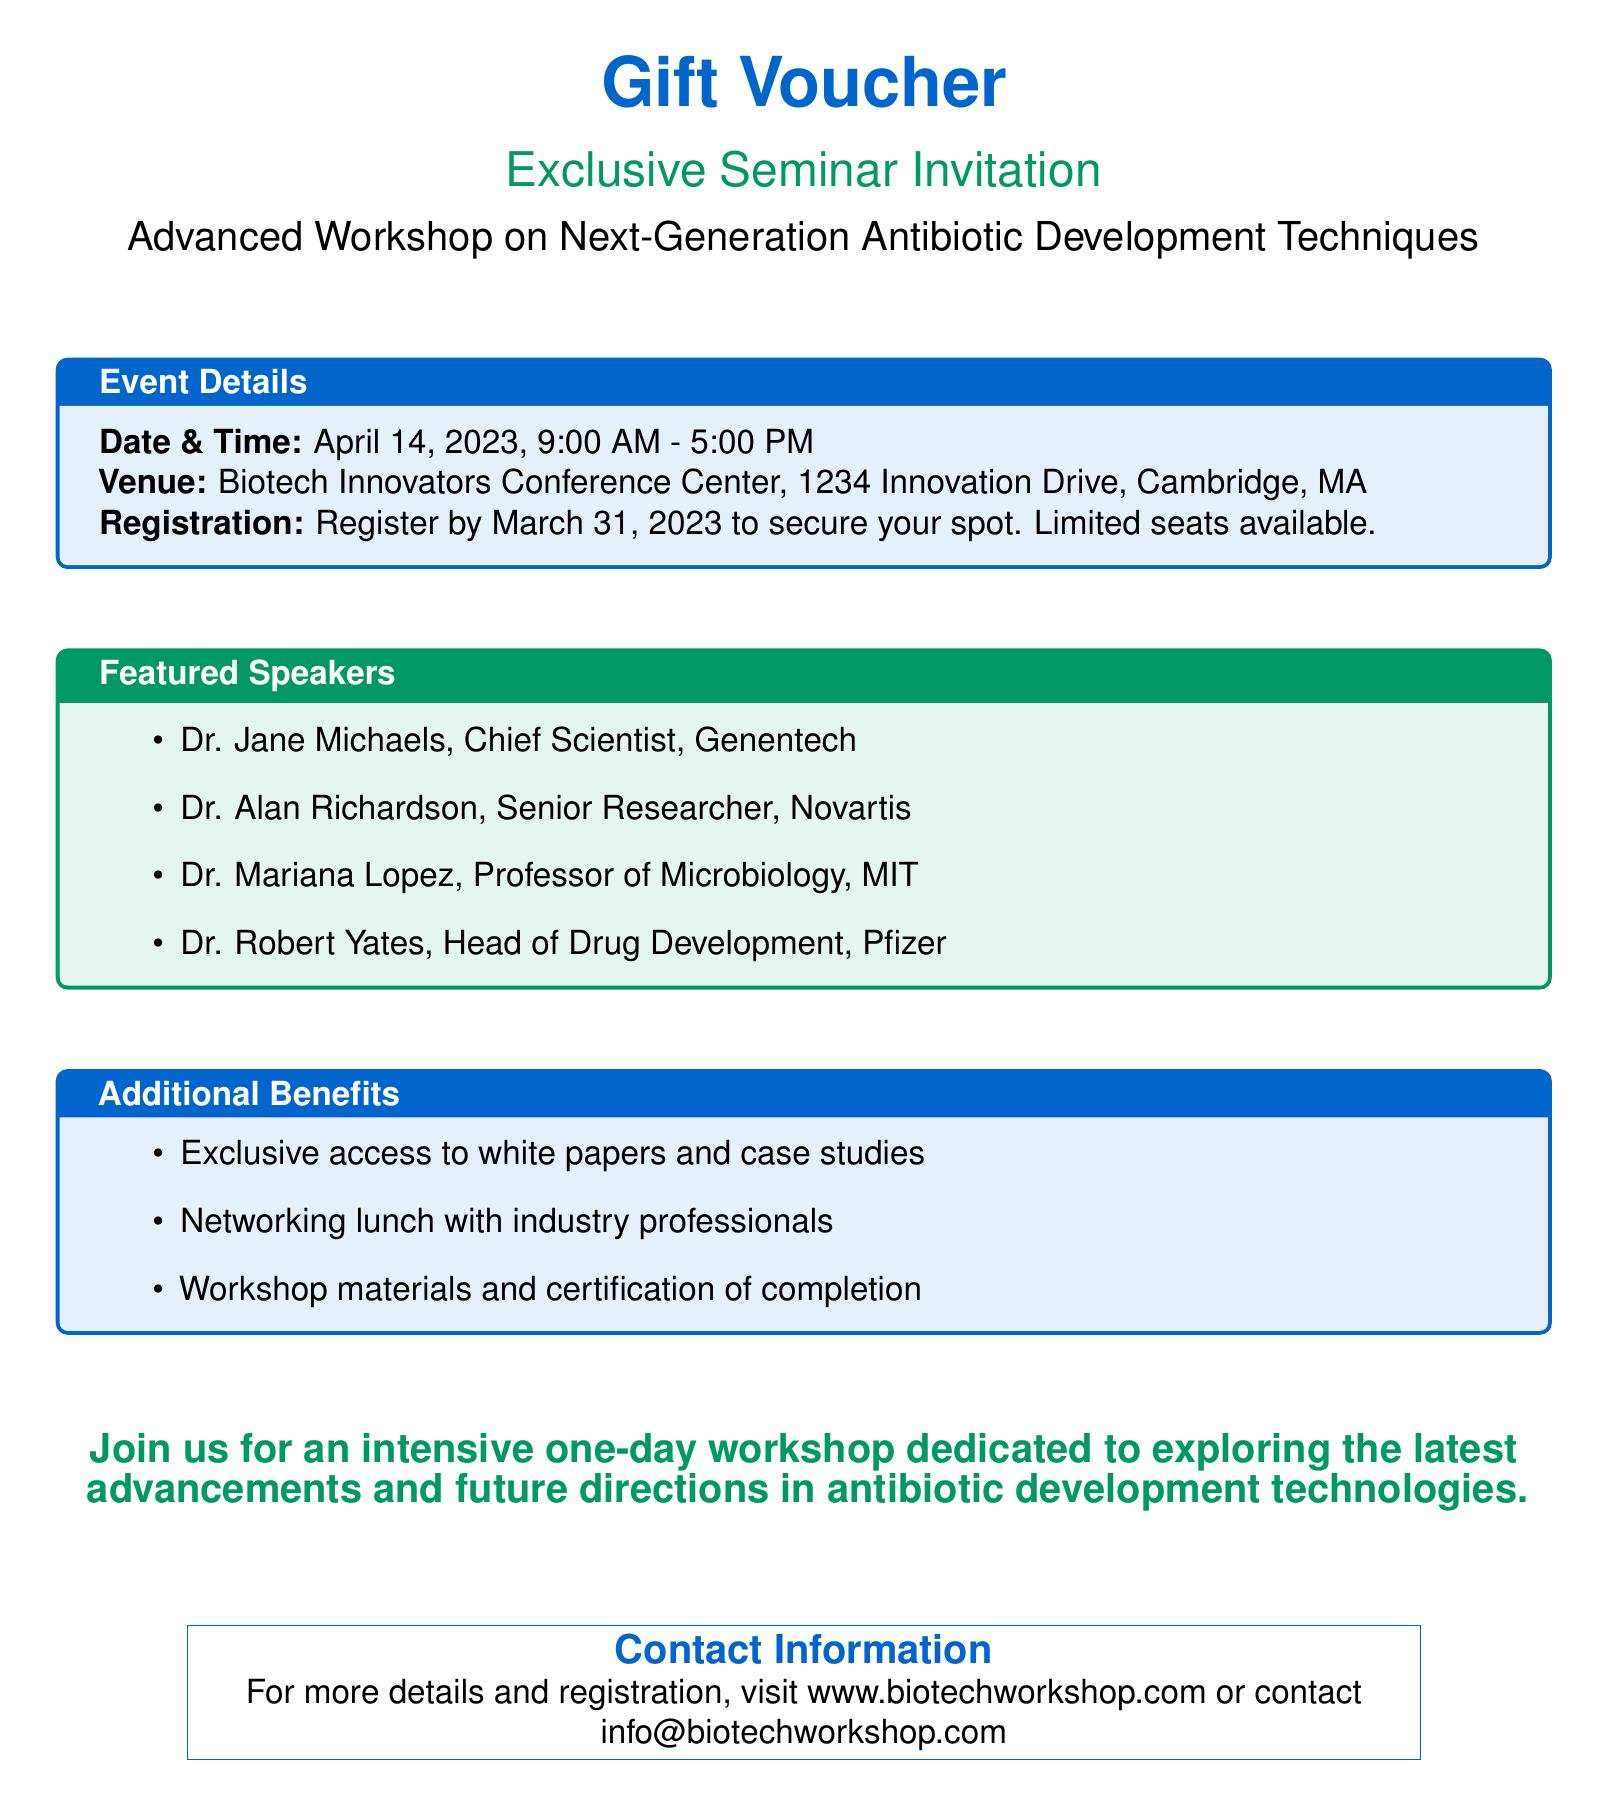What is the date of the workshop? The date of the workshop is specified in the event details section of the document.
Answer: April 14, 2023 What time does the workshop start? The starting time is included in the event details section, which mentions the hours for the workshop.
Answer: 9:00 AM Where is the workshop venue located? The venue location is detailed in the event details section of the document.
Answer: Biotech Innovators Conference Center, 1234 Innovation Drive, Cambridge, MA Who is one of the featured speakers? The featured speakers are listed in a specific section of the document, providing names and positions.
Answer: Dr. Jane Michaels What is the deadline for registration? The registration deadline is mentioned in the event details section of the document.
Answer: March 31, 2023 What type of materials will participants receive? The additional benefits section outlines the type of materials provided to participants.
Answer: Workshop materials and certification of completion How many featured speakers are listed? The number of featured speakers can be counted from the list provided in the document.
Answer: Four What type of lunch is included? The additional benefits section describes the lunch included in the event.
Answer: Networking lunch What is the website for more details? The contact information section provides the website for more details and registration.
Answer: www.biotechworkshop.com 